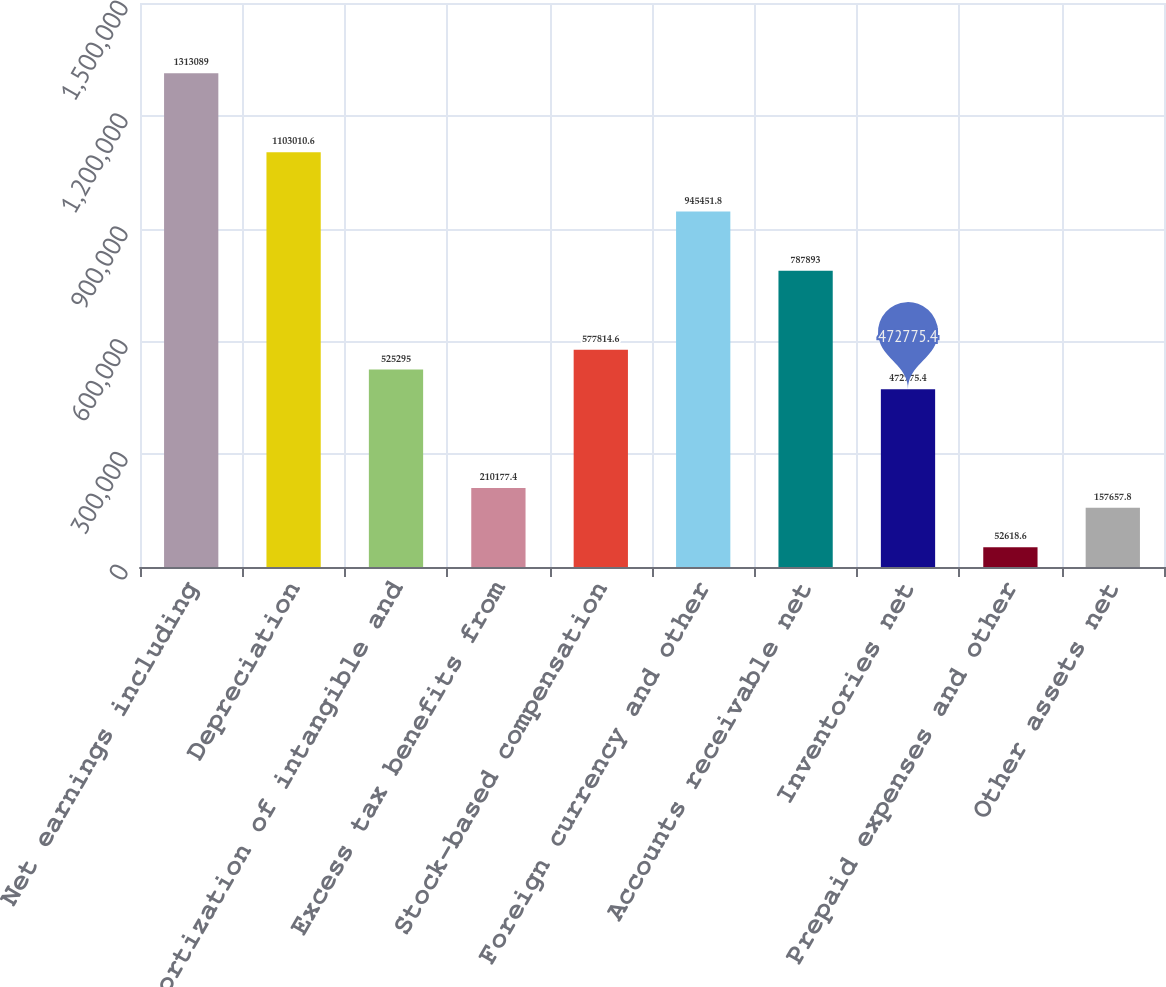<chart> <loc_0><loc_0><loc_500><loc_500><bar_chart><fcel>Net earnings including<fcel>Depreciation<fcel>Amortization of intangible and<fcel>Excess tax benefits from<fcel>Stock-based compensation<fcel>Foreign currency and other<fcel>Accounts receivable net<fcel>Inventories net<fcel>Prepaid expenses and other<fcel>Other assets net<nl><fcel>1.31309e+06<fcel>1.10301e+06<fcel>525295<fcel>210177<fcel>577815<fcel>945452<fcel>787893<fcel>472775<fcel>52618.6<fcel>157658<nl></chart> 